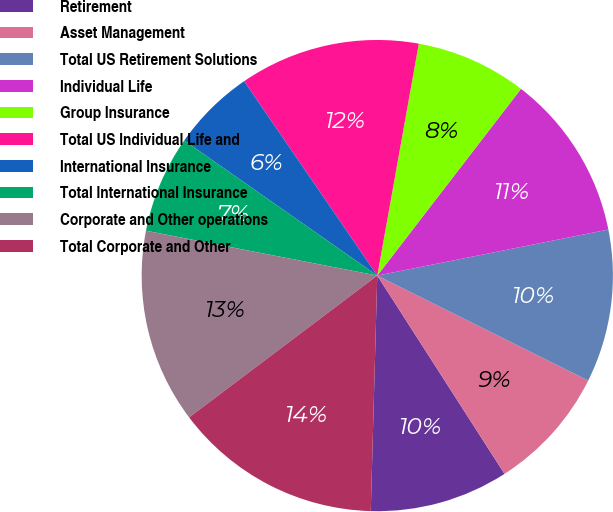<chart> <loc_0><loc_0><loc_500><loc_500><pie_chart><fcel>Retirement<fcel>Asset Management<fcel>Total US Retirement Solutions<fcel>Individual Life<fcel>Group Insurance<fcel>Total US Individual Life and<fcel>International Insurance<fcel>Total International Insurance<fcel>Corporate and Other operations<fcel>Total Corporate and Other<nl><fcel>9.52%<fcel>8.57%<fcel>10.48%<fcel>11.43%<fcel>7.62%<fcel>12.38%<fcel>5.72%<fcel>6.67%<fcel>13.33%<fcel>14.28%<nl></chart> 